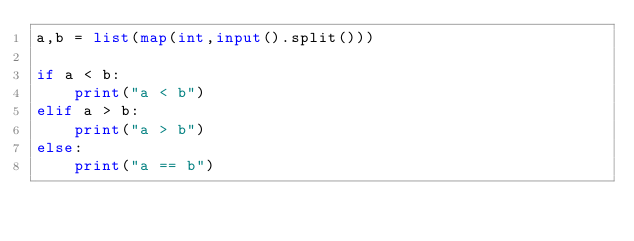Convert code to text. <code><loc_0><loc_0><loc_500><loc_500><_Python_>a,b = list(map(int,input().split()))

if a < b:
    print("a < b")
elif a > b:
    print("a > b")
else:
    print("a == b")</code> 